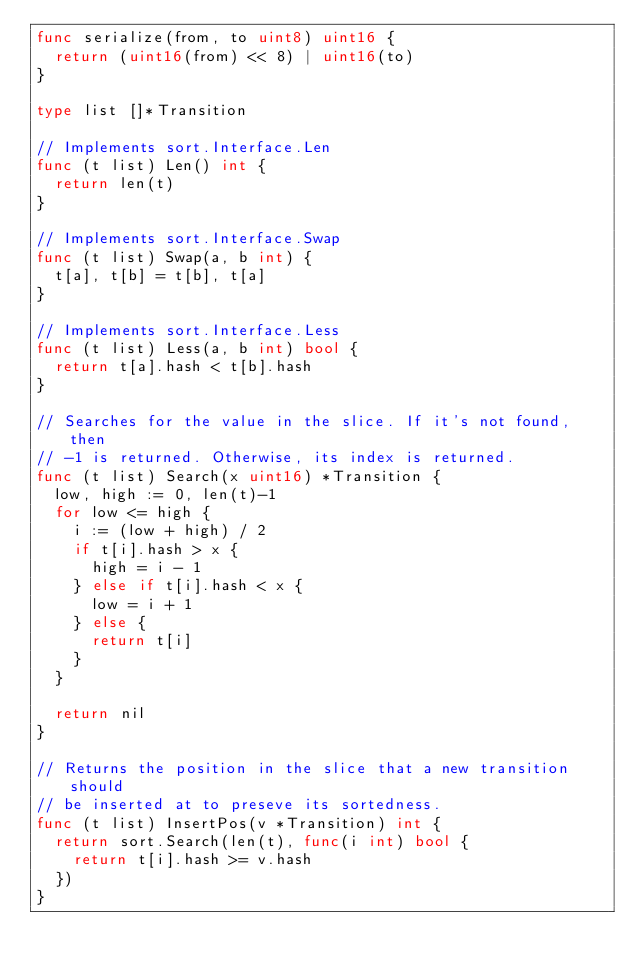Convert code to text. <code><loc_0><loc_0><loc_500><loc_500><_Go_>func serialize(from, to uint8) uint16 {
	return (uint16(from) << 8) | uint16(to)
}

type list []*Transition

// Implements sort.Interface.Len
func (t list) Len() int {
	return len(t)
}

// Implements sort.Interface.Swap
func (t list) Swap(a, b int) {
	t[a], t[b] = t[b], t[a]
}

// Implements sort.Interface.Less
func (t list) Less(a, b int) bool {
	return t[a].hash < t[b].hash
}

// Searches for the value in the slice. If it's not found, then
// -1 is returned. Otherwise, its index is returned.
func (t list) Search(x uint16) *Transition {
	low, high := 0, len(t)-1
	for low <= high {
		i := (low + high) / 2
		if t[i].hash > x {
			high = i - 1
		} else if t[i].hash < x {
			low = i + 1
		} else {
			return t[i]
		}
	}

	return nil
}

// Returns the position in the slice that a new transition should
// be inserted at to preseve its sortedness.
func (t list) InsertPos(v *Transition) int {
	return sort.Search(len(t), func(i int) bool {
		return t[i].hash >= v.hash
	})
}
</code> 